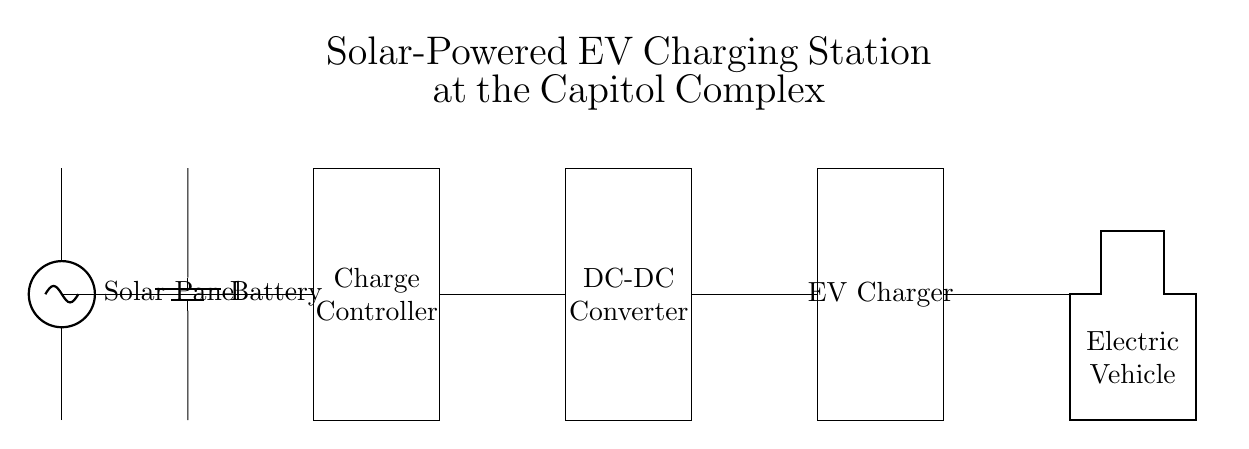What component converts solar energy into electrical energy? The solar panel is the component responsible for converting solar energy into electrical energy. It is depicted at the beginning of the circuit diagram.
Answer: Solar Panel What is the purpose of the charge controller? The charge controller regulates the voltage and current going to the battery from the solar panel, ensuring safe and efficient charging. It is located between the solar panel and the battery in the diagram.
Answer: Regulate voltage and current How many components are involved in the charging process? There are five main components involved: the solar panel, battery, charge controller, DC-DC converter, and EV charger. Each component has a specific function in the charging process.
Answer: Five What does the DC-DC converter do? The DC-DC converter adjusts the voltage level required to charge the electric vehicle efficiently, ensuring compatibility with the EV charger. It is positioned before the EV charger in the circuit.
Answer: Adjust voltage level Which component directly connects to the electric vehicle? The EV charger is the component that directly connects to the electric vehicle, allowing it to receive power for charging. This is the last component in the sequence of the circuit before the electric vehicle.
Answer: EV Charger Why is a battery included in the circuit? The battery stores the energy generated by the solar panel for later use, allowing the EV charger to provide power even when solar energy production is low or absent. It ensures the charging station can operate continuously.
Answer: Store energy What kind of energy conversion takes place in the solar panel? The solar panel performs a conversion of solar energy into electrical energy, utilizing photovoltaic cells to capture sunlight and transform it into usable electricity.
Answer: Solar to electrical 